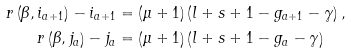Convert formula to latex. <formula><loc_0><loc_0><loc_500><loc_500>r \left ( \beta , i _ { a + 1 } \right ) - i _ { a + 1 } & = \left ( \mu + 1 \right ) \left ( l + s + 1 - g _ { a + 1 } - \gamma \right ) , \\ r \left ( \beta , j _ { a } \right ) - j _ { a } & = \left ( \mu + 1 \right ) \left ( l + s + 1 - g _ { a } - \gamma \right )</formula> 